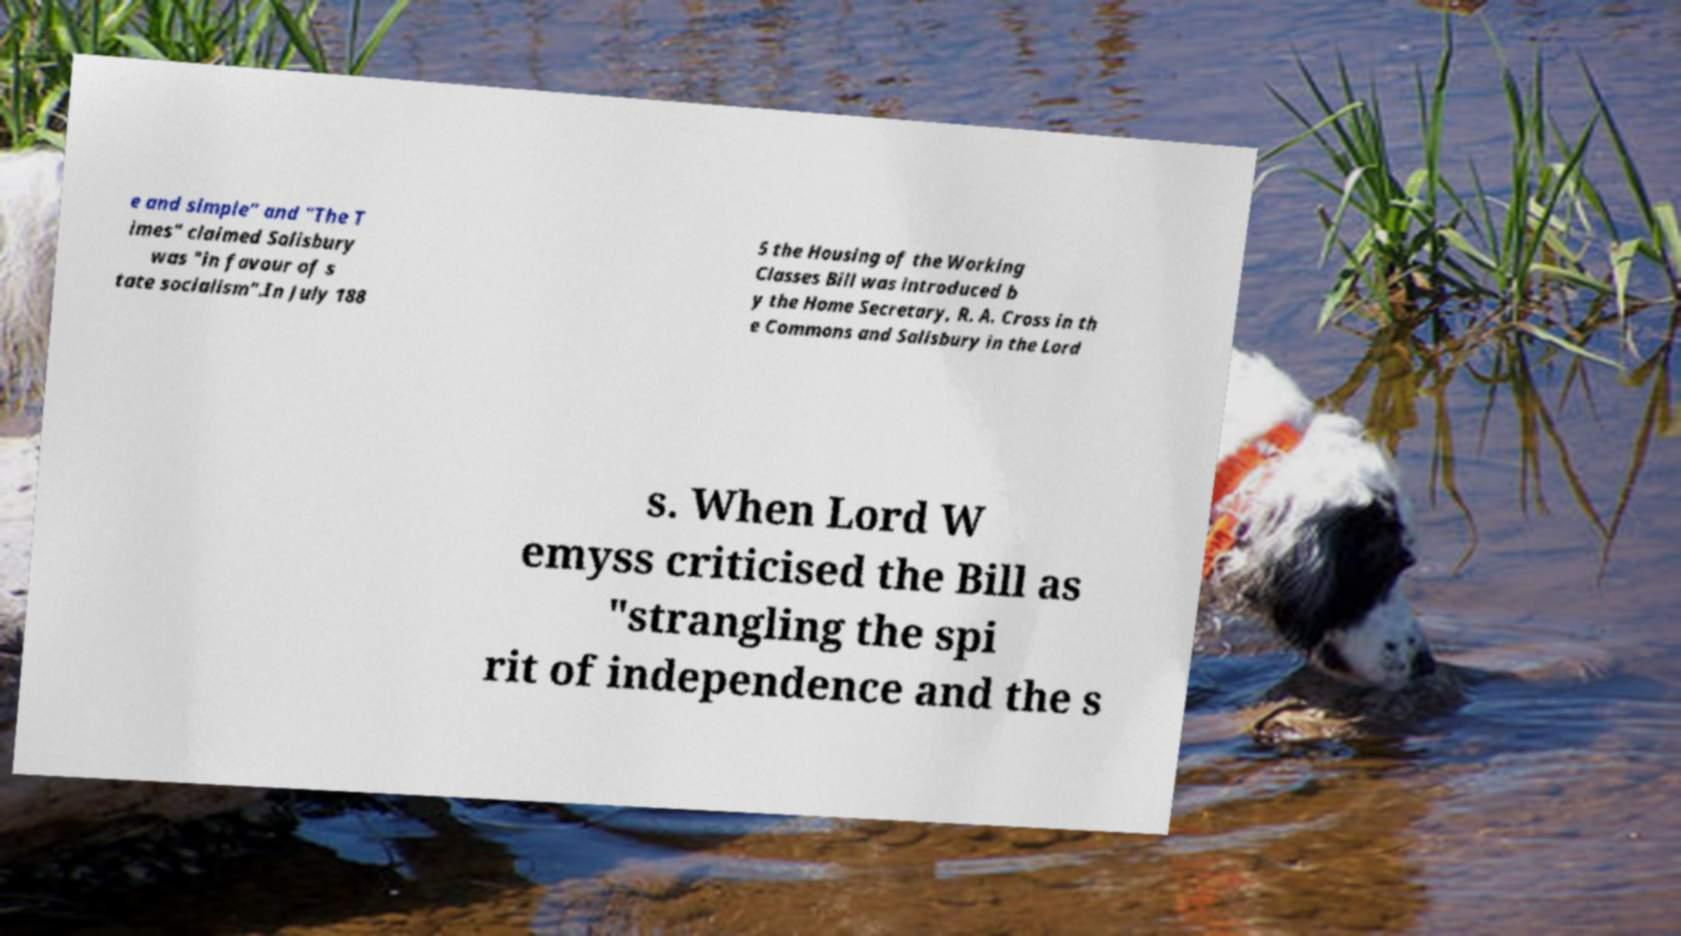Can you read and provide the text displayed in the image?This photo seems to have some interesting text. Can you extract and type it out for me? e and simple" and "The T imes" claimed Salisbury was "in favour of s tate socialism".In July 188 5 the Housing of the Working Classes Bill was introduced b y the Home Secretary, R. A. Cross in th e Commons and Salisbury in the Lord s. When Lord W emyss criticised the Bill as "strangling the spi rit of independence and the s 